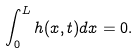<formula> <loc_0><loc_0><loc_500><loc_500>\int _ { 0 } ^ { L } h ( x , t ) d x = 0 .</formula> 